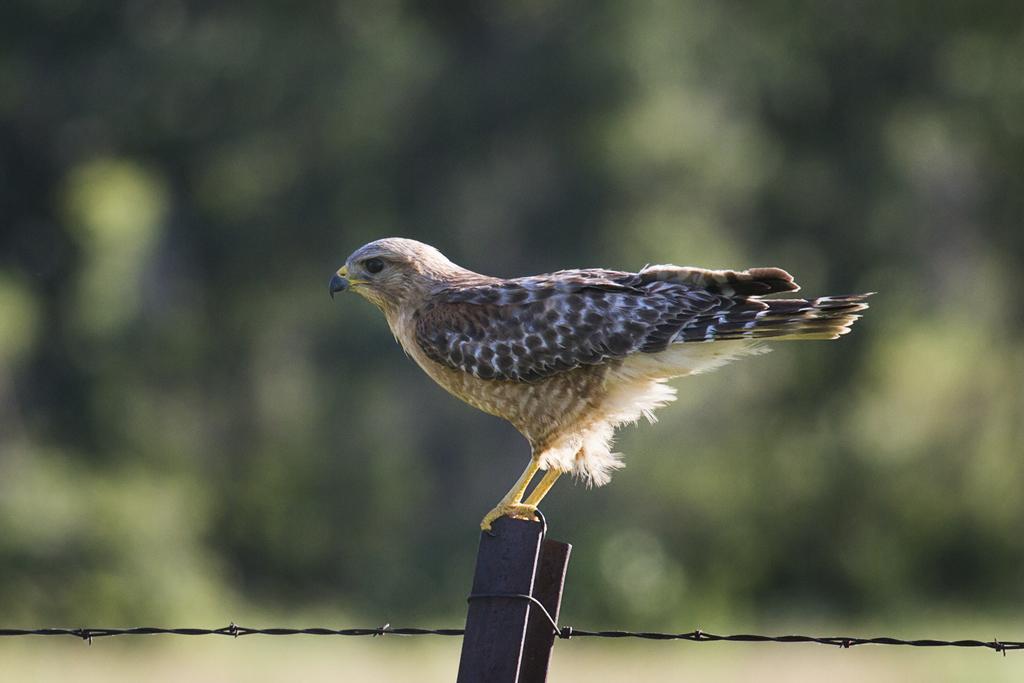Can you describe this image briefly? In the center of the image a bird is standing on a pole. At the bottom of the image fencing is there. In the background the image is blur. 